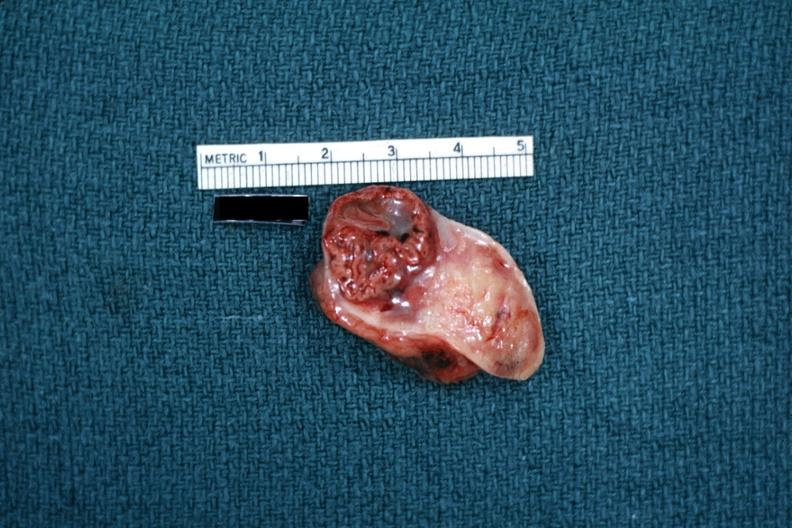s female reproductive present?
Answer the question using a single word or phrase. Yes 